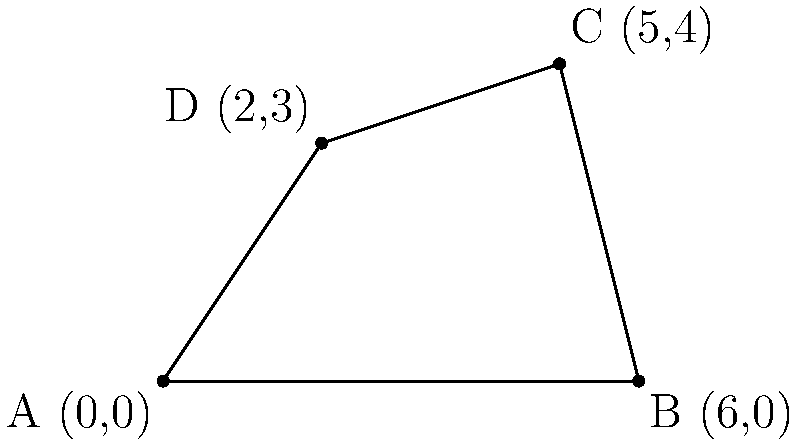You've been measuring your wheat field using a new GPS device, and you've plotted the corners on this here graph paper. The field is shaped like an irregular quadrilateral with corners at A(0,0), B(6,0), C(5,4), and D(2,3). Now, you're wondering how to figure out the area without walking the whole field. Can you calculate the area of this field in square units using this newfangled coordinate method? Let's break this down step-by-step using a method that doesn't require any fancy calculators:

1) We can split this irregular quadrilateral into two triangles: ABC and ACD.

2) For triangle ABC:
   Base = 6 units (from A to B)
   Height = 4 units (from B to C)
   Area of ABC = $\frac{1}{2} \times 6 \times 4 = 12$ square units

3) For triangle ACD:
   We can use the formula: Area = $\frac{1}{2}|x_1(y_2 - y_3) + x_2(y_3 - y_1) + x_3(y_1 - y_2)|$
   Where (x1,y1) = A(0,0), (x2,y2) = C(5,4), (x3,y3) = D(2,3)

   Area of ACD = $\frac{1}{2}|0(4 - 3) + 5(3 - 0) + 2(0 - 4)|$
                = $\frac{1}{2}|0 + 15 - 8|$
                = $\frac{1}{2} \times 7 = 3.5$ square units

4) Total area = Area of ABC + Area of ACD
               = 12 + 3.5 = 15.5 square units

Thus, the area of your field is 15.5 square units.
Answer: 15.5 square units 